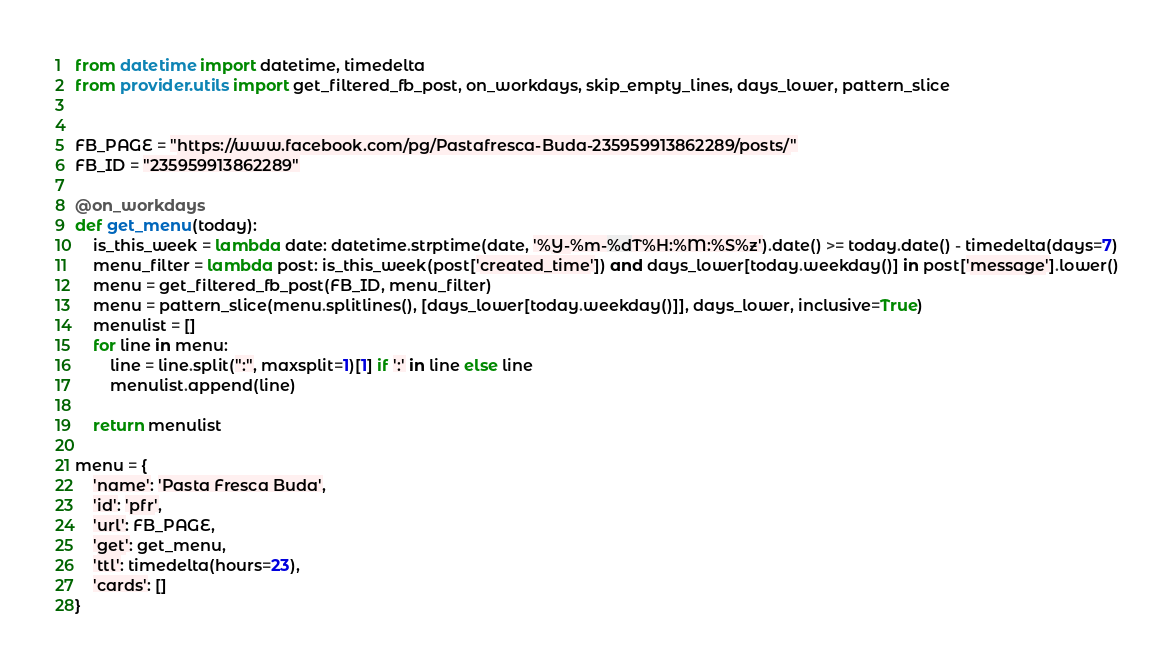Convert code to text. <code><loc_0><loc_0><loc_500><loc_500><_Python_>from datetime import datetime, timedelta
from provider.utils import get_filtered_fb_post, on_workdays, skip_empty_lines, days_lower, pattern_slice


FB_PAGE = "https://www.facebook.com/pg/Pastafresca-Buda-235959913862289/posts/"
FB_ID = "235959913862289"

@on_workdays
def get_menu(today):
    is_this_week = lambda date: datetime.strptime(date, '%Y-%m-%dT%H:%M:%S%z').date() >= today.date() - timedelta(days=7)
    menu_filter = lambda post: is_this_week(post['created_time']) and days_lower[today.weekday()] in post['message'].lower()
    menu = get_filtered_fb_post(FB_ID, menu_filter)
    menu = pattern_slice(menu.splitlines(), [days_lower[today.weekday()]], days_lower, inclusive=True)
    menulist = []
    for line in menu:
        line = line.split(":", maxsplit=1)[1] if ':' in line else line
        menulist.append(line)

    return menulist

menu = {
    'name': 'Pasta Fresca Buda',
    'id': 'pfr',
    'url': FB_PAGE,
    'get': get_menu,
    'ttl': timedelta(hours=23),
    'cards': []
}
</code> 